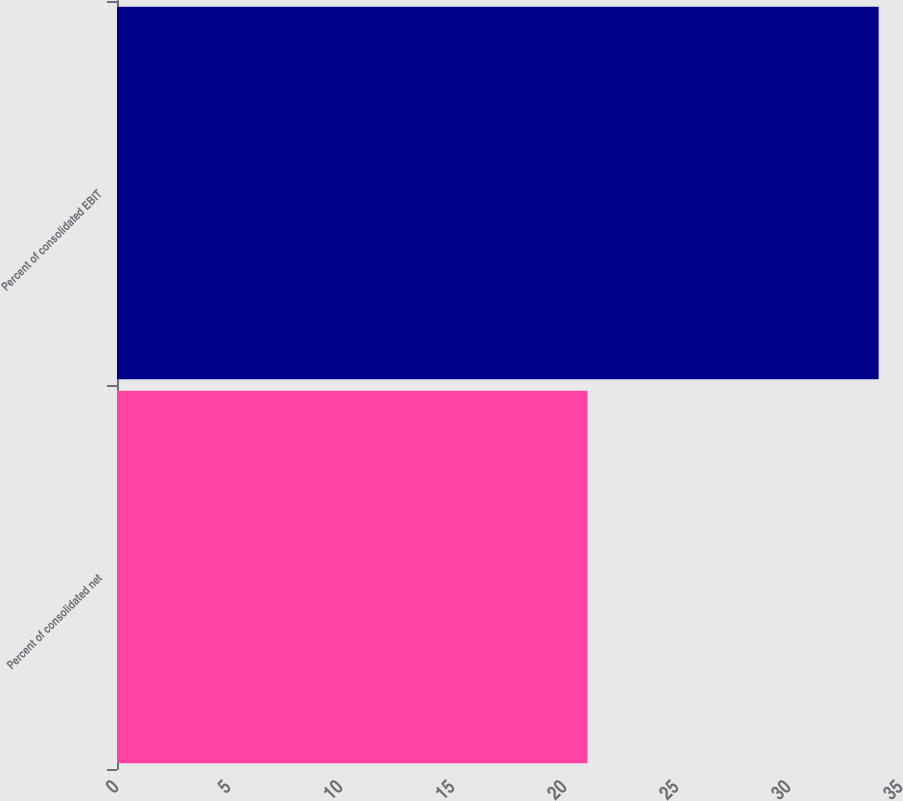<chart> <loc_0><loc_0><loc_500><loc_500><bar_chart><fcel>Percent of consolidated net<fcel>Percent of consolidated EBIT<nl><fcel>21<fcel>34<nl></chart> 